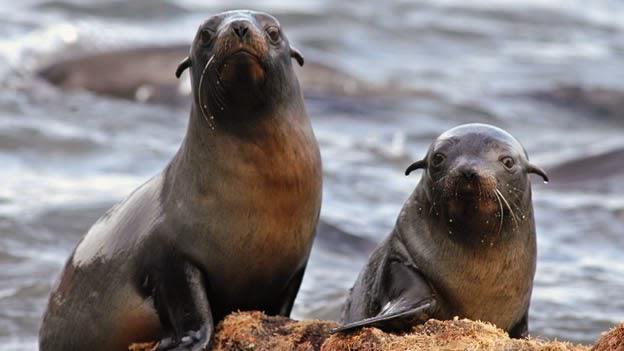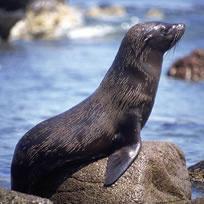The first image is the image on the left, the second image is the image on the right. Assess this claim about the two images: "An image contains at least two seals.". Correct or not? Answer yes or no. Yes. 